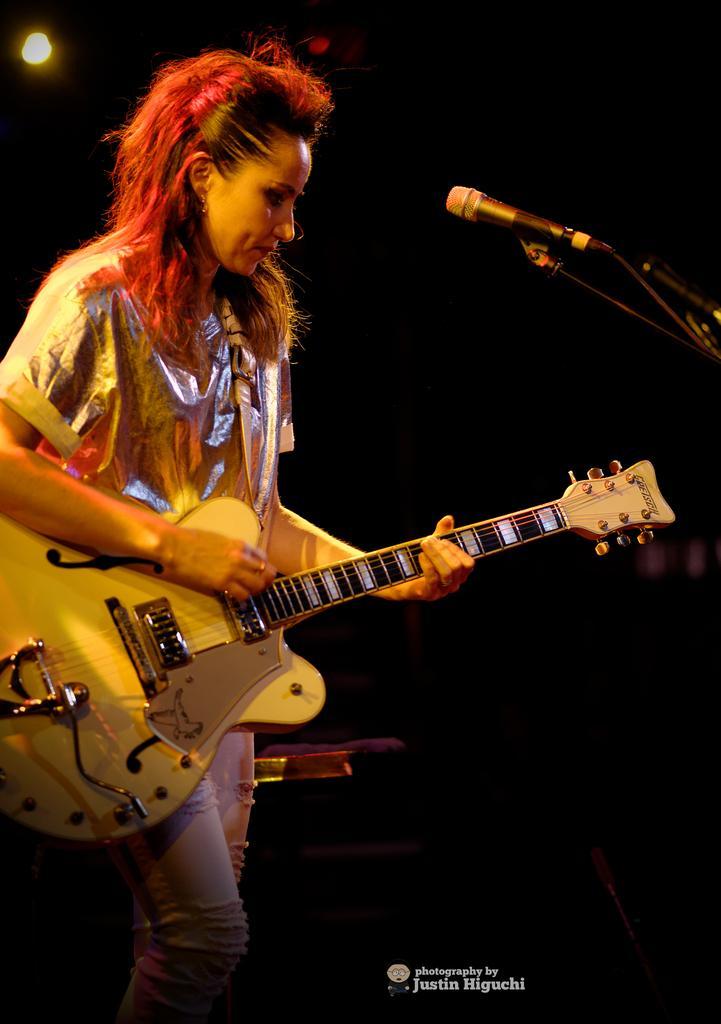In one or two sentences, can you explain what this image depicts? This woman is playing guitar in-front of mic and wire silver color t-shirt. On top there is a focusing light. 